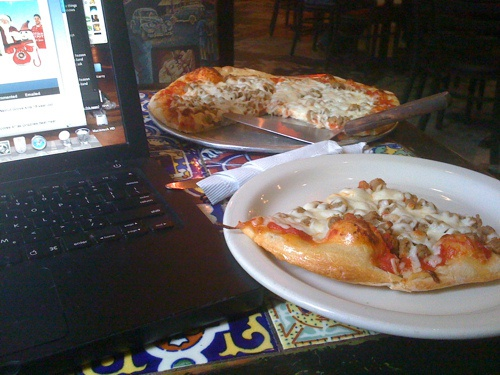Describe the objects in this image and their specific colors. I can see laptop in white, black, and gray tones, pizza in white, brown, darkgray, tan, and gray tones, dining table in white, black, navy, tan, and olive tones, chair in white, black, maroon, and gray tones, and pizza in white, darkgray, tan, and brown tones in this image. 